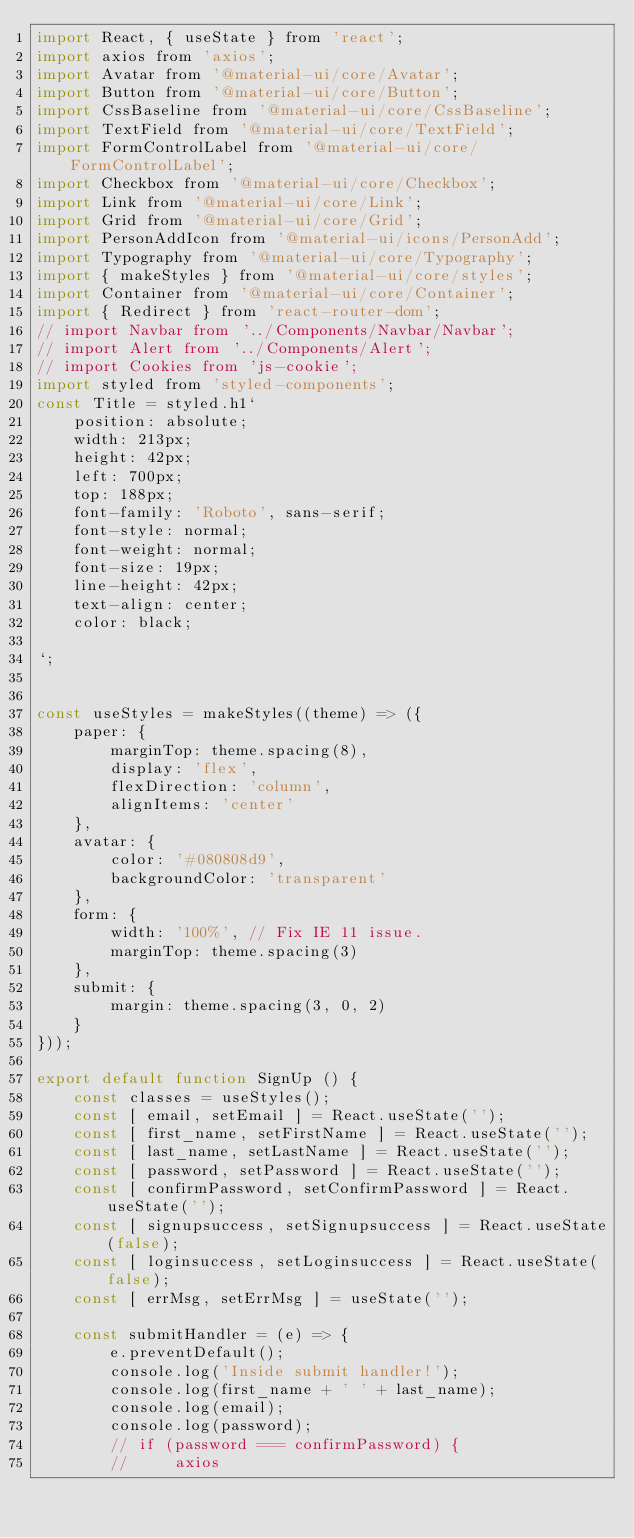Convert code to text. <code><loc_0><loc_0><loc_500><loc_500><_JavaScript_>import React, { useState } from 'react';
import axios from 'axios';
import Avatar from '@material-ui/core/Avatar';
import Button from '@material-ui/core/Button';
import CssBaseline from '@material-ui/core/CssBaseline';
import TextField from '@material-ui/core/TextField';
import FormControlLabel from '@material-ui/core/FormControlLabel';
import Checkbox from '@material-ui/core/Checkbox';
import Link from '@material-ui/core/Link';
import Grid from '@material-ui/core/Grid';
import PersonAddIcon from '@material-ui/icons/PersonAdd';
import Typography from '@material-ui/core/Typography';
import { makeStyles } from '@material-ui/core/styles';
import Container from '@material-ui/core/Container';
import { Redirect } from 'react-router-dom';
// import Navbar from '../Components/Navbar/Navbar';
// import Alert from '../Components/Alert';
// import Cookies from 'js-cookie';
import styled from 'styled-components';
const Title = styled.h1`
    position: absolute;
    width: 213px;
    height: 42px;
    left: 700px;
    top: 188px;
    font-family: 'Roboto', sans-serif;
    font-style: normal;
    font-weight: normal;
    font-size: 19px;
    line-height: 42px;
    text-align: center;
    color: black;

`;


const useStyles = makeStyles((theme) => ({
	paper: {
		marginTop: theme.spacing(8),
		display: 'flex',
		flexDirection: 'column',
		alignItems: 'center'
	},
	avatar: {
		color: '#080808d9',
		backgroundColor: 'transparent'
	},
	form: {
		width: '100%', // Fix IE 11 issue.
		marginTop: theme.spacing(3)
	},
	submit: {
		margin: theme.spacing(3, 0, 2)
	}
}));

export default function SignUp () {
	const classes = useStyles();
	const [ email, setEmail ] = React.useState('');
	const [ first_name, setFirstName ] = React.useState('');
	const [ last_name, setLastName ] = React.useState('');
	const [ password, setPassword ] = React.useState('');
	const [ confirmPassword, setConfirmPassword ] = React.useState('');
	const [ signupsuccess, setSignupsuccess ] = React.useState(false);
	const [ loginsuccess, setLoginsuccess ] = React.useState(false);
	const [ errMsg, setErrMsg ] = useState('');

	const submitHandler = (e) => {
		e.preventDefault();
		console.log('Inside submit handler!');
		console.log(first_name + ' ' + last_name);
		console.log(email);
		console.log(password);
		// if (password === confirmPassword) {
        //     axios</code> 